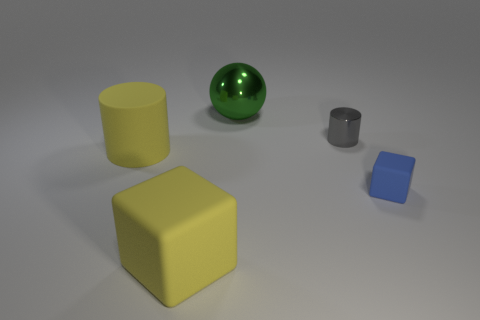What is the size of the metallic thing that is in front of the big thing that is behind the gray cylinder?
Ensure brevity in your answer.  Small. Is the number of green objects that are in front of the big green object the same as the number of cylinders that are in front of the tiny blue rubber block?
Give a very brief answer. Yes. There is a thing that is on the right side of the big green object and to the left of the blue block; what material is it?
Ensure brevity in your answer.  Metal. Do the green metal thing and the cylinder that is left of the metallic ball have the same size?
Your answer should be compact. Yes. How many other things are the same color as the large rubber cylinder?
Your response must be concise. 1. Is the number of large yellow things that are in front of the gray shiny cylinder greater than the number of large yellow spheres?
Provide a succinct answer. Yes. There is a cylinder right of the yellow object that is on the left side of the object that is in front of the small blue cube; what is its color?
Provide a succinct answer. Gray. Does the tiny gray cylinder have the same material as the large cylinder?
Provide a succinct answer. No. Is there a cylinder of the same size as the blue rubber block?
Your answer should be compact. Yes. There is a yellow cylinder that is the same size as the metallic sphere; what is its material?
Your answer should be compact. Rubber. 